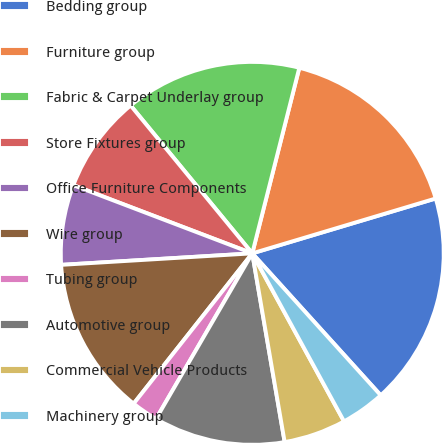Convert chart. <chart><loc_0><loc_0><loc_500><loc_500><pie_chart><fcel>Bedding group<fcel>Furniture group<fcel>Fabric & Carpet Underlay group<fcel>Store Fixtures group<fcel>Office Furniture Components<fcel>Wire group<fcel>Tubing group<fcel>Automotive group<fcel>Commercial Vehicle Products<fcel>Machinery group<nl><fcel>17.92%<fcel>16.42%<fcel>14.91%<fcel>8.25%<fcel>6.75%<fcel>13.41%<fcel>2.25%<fcel>11.09%<fcel>5.25%<fcel>3.75%<nl></chart> 